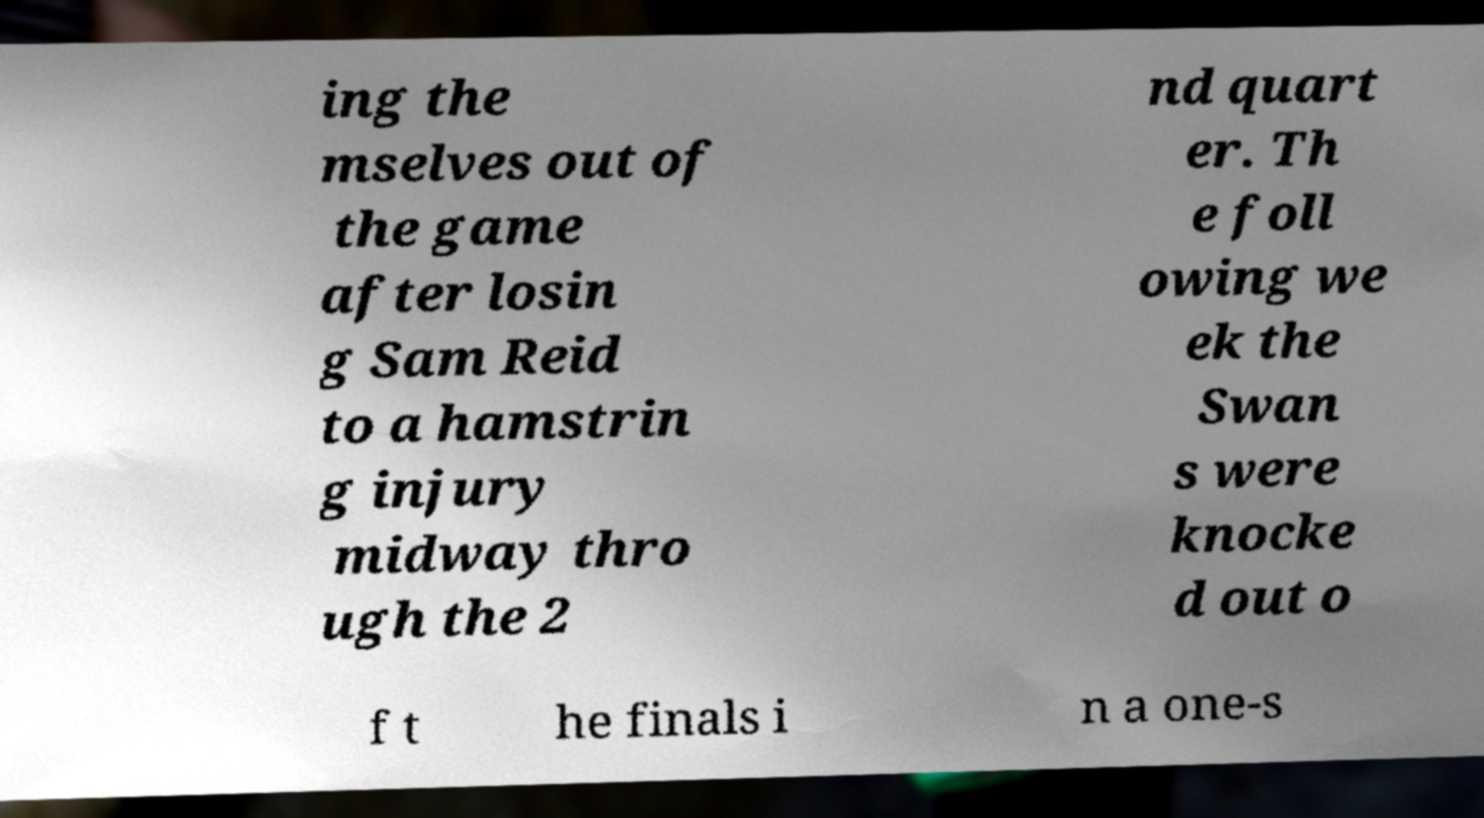Can you read and provide the text displayed in the image?This photo seems to have some interesting text. Can you extract and type it out for me? ing the mselves out of the game after losin g Sam Reid to a hamstrin g injury midway thro ugh the 2 nd quart er. Th e foll owing we ek the Swan s were knocke d out o f t he finals i n a one-s 